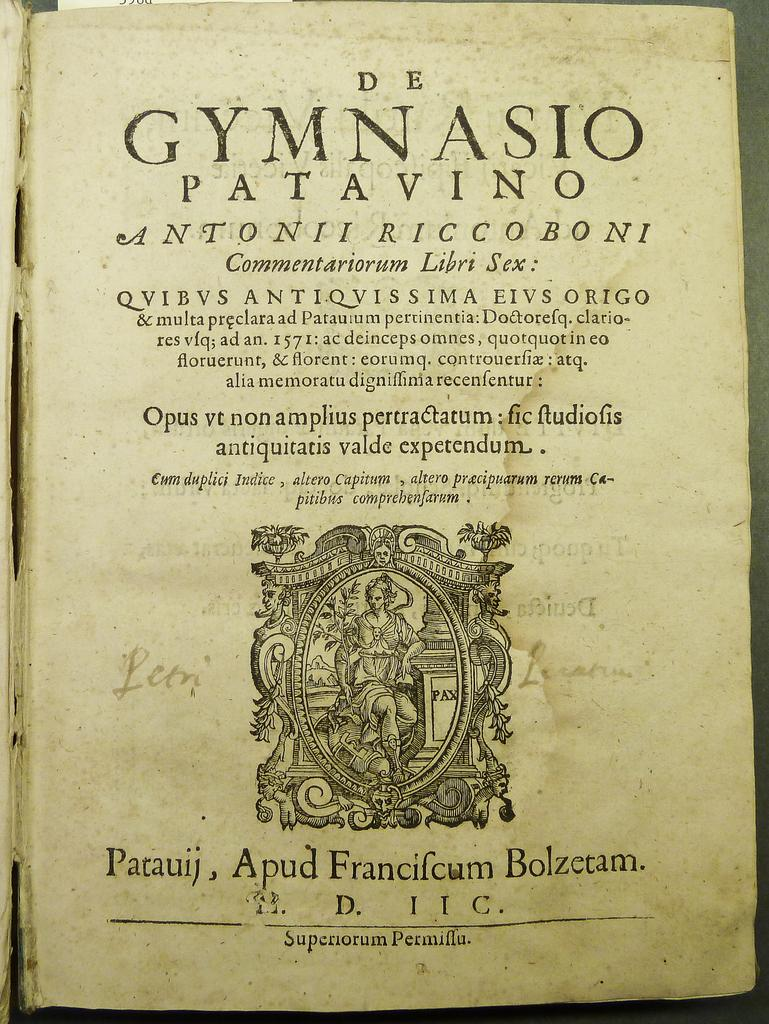<image>
Create a compact narrative representing the image presented. The de gymnasio patavino book that is old 